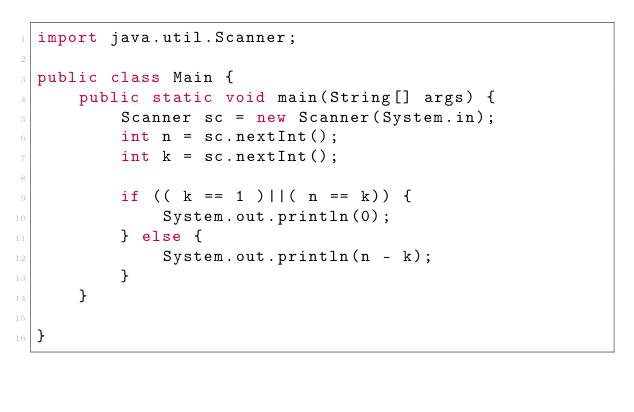Convert code to text. <code><loc_0><loc_0><loc_500><loc_500><_Java_>import java.util.Scanner;

public class Main {
	public static void main(String[] args) {
		Scanner sc = new Scanner(System.in);
		int n = sc.nextInt();
		int k = sc.nextInt();

		if (( k == 1 )||( n == k)) {
			System.out.println(0);
		} else {
			System.out.println(n - k);
		}
	}

}
</code> 